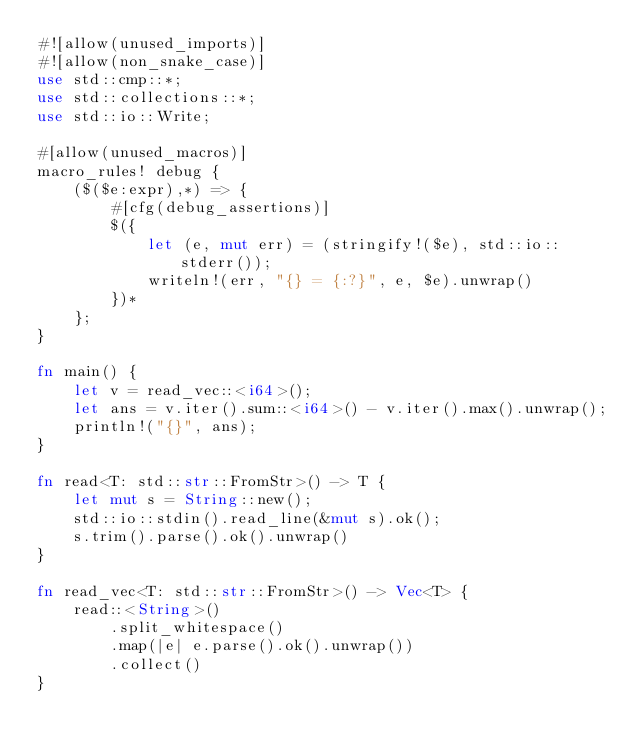Convert code to text. <code><loc_0><loc_0><loc_500><loc_500><_Rust_>#![allow(unused_imports)]
#![allow(non_snake_case)]
use std::cmp::*;
use std::collections::*;
use std::io::Write;

#[allow(unused_macros)]
macro_rules! debug {
    ($($e:expr),*) => {
        #[cfg(debug_assertions)]
        $({
            let (e, mut err) = (stringify!($e), std::io::stderr());
            writeln!(err, "{} = {:?}", e, $e).unwrap()
        })*
    };
}

fn main() {
    let v = read_vec::<i64>();
    let ans = v.iter().sum::<i64>() - v.iter().max().unwrap();
    println!("{}", ans);
}

fn read<T: std::str::FromStr>() -> T {
    let mut s = String::new();
    std::io::stdin().read_line(&mut s).ok();
    s.trim().parse().ok().unwrap()
}

fn read_vec<T: std::str::FromStr>() -> Vec<T> {
    read::<String>()
        .split_whitespace()
        .map(|e| e.parse().ok().unwrap())
        .collect()
}
</code> 